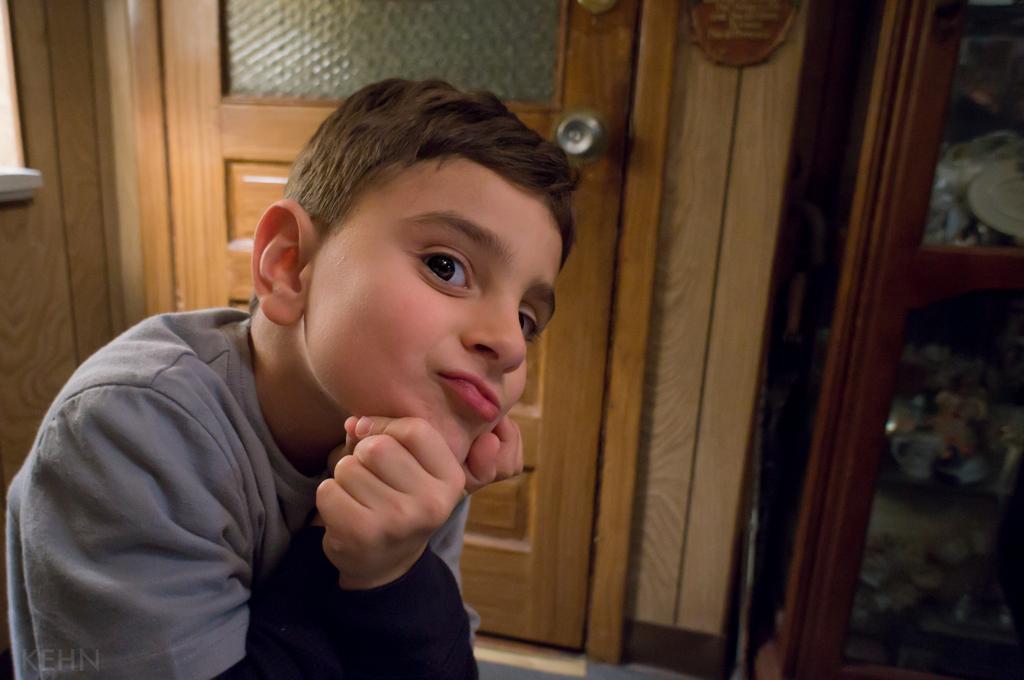Could you give a brief overview of what you see in this image? On the left side, there is a boy in gray color t-shirt, smiling. In the background, there is a wooden door and there is a cupboard. 